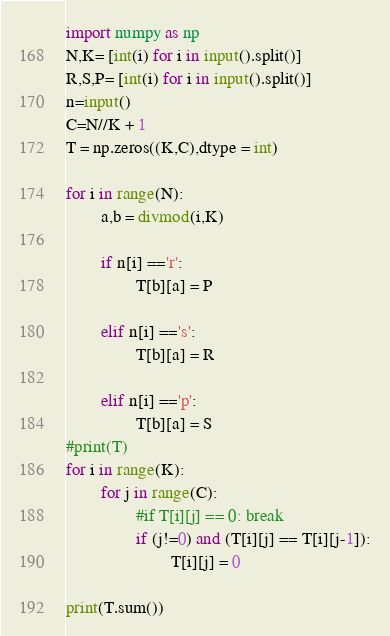Convert code to text. <code><loc_0><loc_0><loc_500><loc_500><_Python_>import numpy as np
N,K= [int(i) for i in input().split()]
R,S,P= [int(i) for i in input().split()]
n=input()
C=N//K + 1
T = np.zeros((K,C),dtype = int)

for i in range(N):
        a,b = divmod(i,K)
        
        if n[i] =='r':
                T[b][a] = P
                
        elif n[i] =='s':         
                T[b][a] = R
                
        elif n[i] =='p':
                T[b][a] = S
#print(T)
for i in range(K):
        for j in range(C):
                #if T[i][j] == 0: break
                if (j!=0) and (T[i][j] == T[i][j-1]):
                        T[i][j] = 0
                        
print(T.sum())</code> 